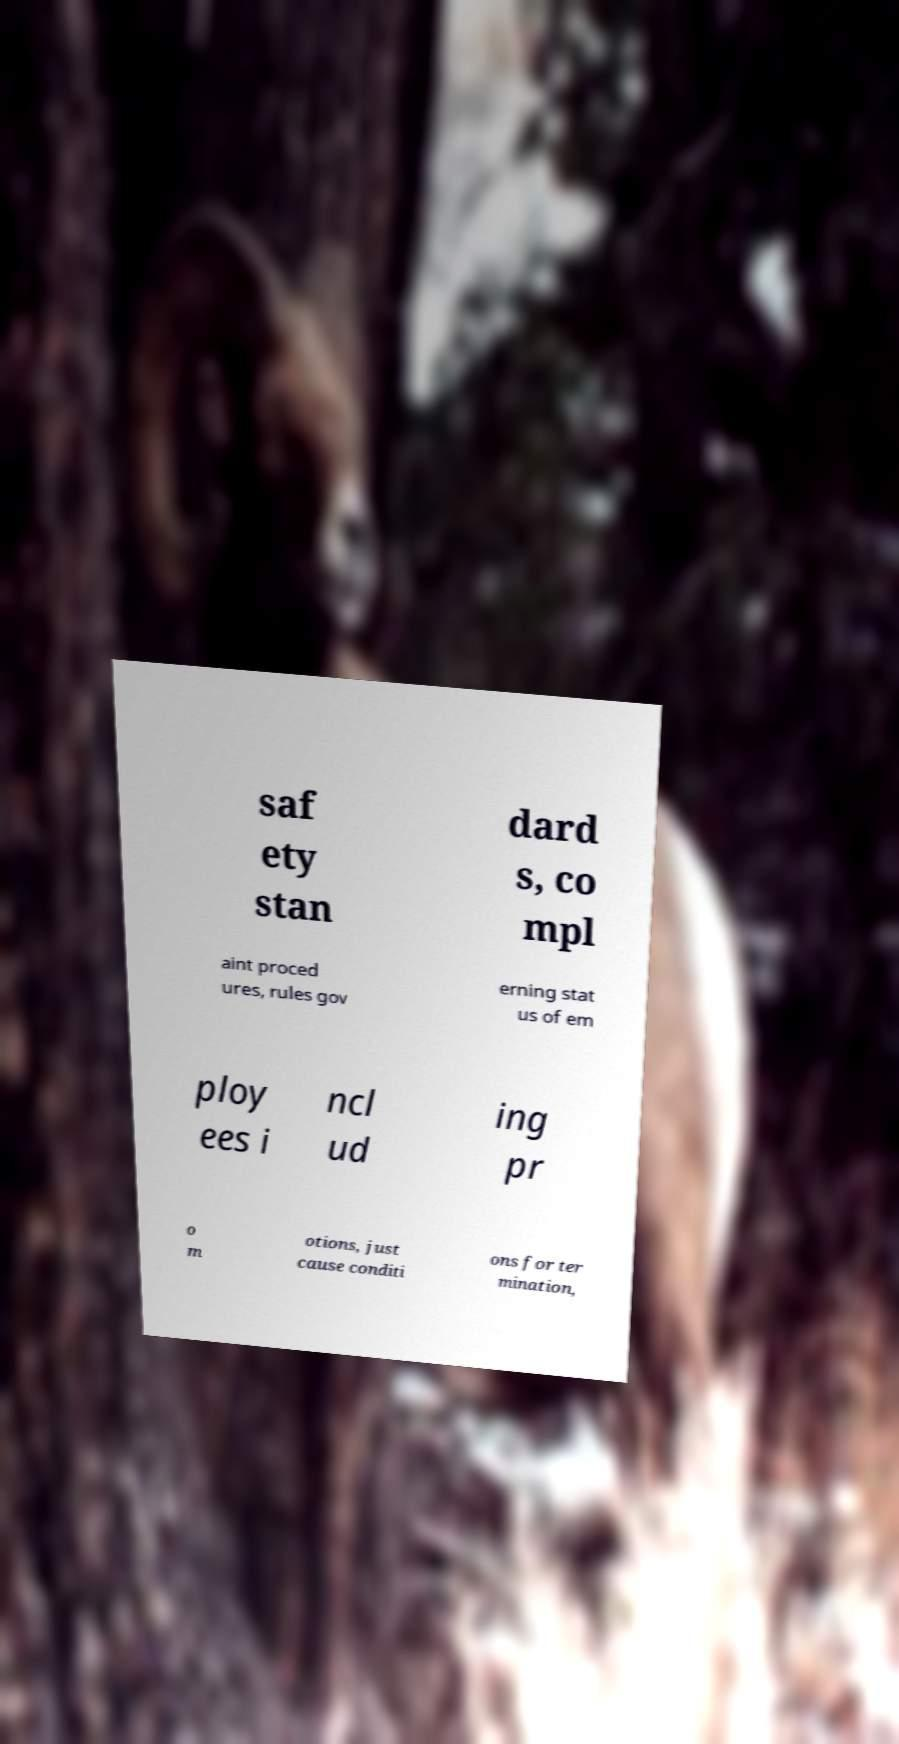Can you accurately transcribe the text from the provided image for me? saf ety stan dard s, co mpl aint proced ures, rules gov erning stat us of em ploy ees i ncl ud ing pr o m otions, just cause conditi ons for ter mination, 